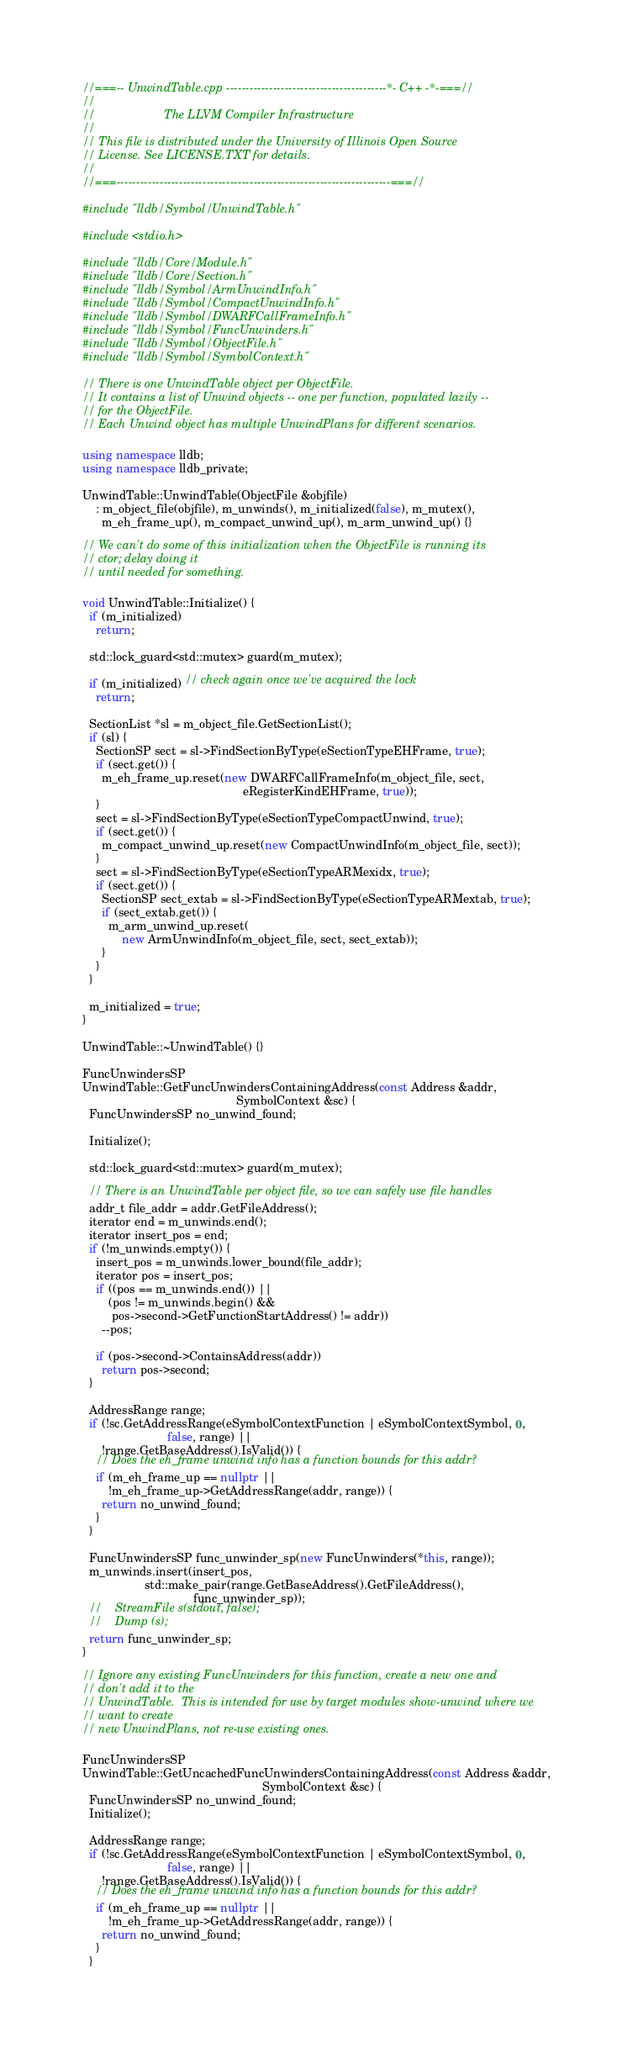<code> <loc_0><loc_0><loc_500><loc_500><_C++_>//===-- UnwindTable.cpp -----------------------------------------*- C++ -*-===//
//
//                     The LLVM Compiler Infrastructure
//
// This file is distributed under the University of Illinois Open Source
// License. See LICENSE.TXT for details.
//
//===----------------------------------------------------------------------===//

#include "lldb/Symbol/UnwindTable.h"

#include <stdio.h>

#include "lldb/Core/Module.h"
#include "lldb/Core/Section.h"
#include "lldb/Symbol/ArmUnwindInfo.h"
#include "lldb/Symbol/CompactUnwindInfo.h"
#include "lldb/Symbol/DWARFCallFrameInfo.h"
#include "lldb/Symbol/FuncUnwinders.h"
#include "lldb/Symbol/ObjectFile.h"
#include "lldb/Symbol/SymbolContext.h"

// There is one UnwindTable object per ObjectFile.
// It contains a list of Unwind objects -- one per function, populated lazily --
// for the ObjectFile.
// Each Unwind object has multiple UnwindPlans for different scenarios.

using namespace lldb;
using namespace lldb_private;

UnwindTable::UnwindTable(ObjectFile &objfile)
    : m_object_file(objfile), m_unwinds(), m_initialized(false), m_mutex(),
      m_eh_frame_up(), m_compact_unwind_up(), m_arm_unwind_up() {}

// We can't do some of this initialization when the ObjectFile is running its
// ctor; delay doing it
// until needed for something.

void UnwindTable::Initialize() {
  if (m_initialized)
    return;

  std::lock_guard<std::mutex> guard(m_mutex);

  if (m_initialized) // check again once we've acquired the lock
    return;

  SectionList *sl = m_object_file.GetSectionList();
  if (sl) {
    SectionSP sect = sl->FindSectionByType(eSectionTypeEHFrame, true);
    if (sect.get()) {
      m_eh_frame_up.reset(new DWARFCallFrameInfo(m_object_file, sect,
                                                 eRegisterKindEHFrame, true));
    }
    sect = sl->FindSectionByType(eSectionTypeCompactUnwind, true);
    if (sect.get()) {
      m_compact_unwind_up.reset(new CompactUnwindInfo(m_object_file, sect));
    }
    sect = sl->FindSectionByType(eSectionTypeARMexidx, true);
    if (sect.get()) {
      SectionSP sect_extab = sl->FindSectionByType(eSectionTypeARMextab, true);
      if (sect_extab.get()) {
        m_arm_unwind_up.reset(
            new ArmUnwindInfo(m_object_file, sect, sect_extab));
      }
    }
  }

  m_initialized = true;
}

UnwindTable::~UnwindTable() {}

FuncUnwindersSP
UnwindTable::GetFuncUnwindersContainingAddress(const Address &addr,
                                               SymbolContext &sc) {
  FuncUnwindersSP no_unwind_found;

  Initialize();

  std::lock_guard<std::mutex> guard(m_mutex);

  // There is an UnwindTable per object file, so we can safely use file handles
  addr_t file_addr = addr.GetFileAddress();
  iterator end = m_unwinds.end();
  iterator insert_pos = end;
  if (!m_unwinds.empty()) {
    insert_pos = m_unwinds.lower_bound(file_addr);
    iterator pos = insert_pos;
    if ((pos == m_unwinds.end()) ||
        (pos != m_unwinds.begin() &&
         pos->second->GetFunctionStartAddress() != addr))
      --pos;

    if (pos->second->ContainsAddress(addr))
      return pos->second;
  }

  AddressRange range;
  if (!sc.GetAddressRange(eSymbolContextFunction | eSymbolContextSymbol, 0,
                          false, range) ||
      !range.GetBaseAddress().IsValid()) {
    // Does the eh_frame unwind info has a function bounds for this addr?
    if (m_eh_frame_up == nullptr ||
        !m_eh_frame_up->GetAddressRange(addr, range)) {
      return no_unwind_found;
    }
  }

  FuncUnwindersSP func_unwinder_sp(new FuncUnwinders(*this, range));
  m_unwinds.insert(insert_pos,
                   std::make_pair(range.GetBaseAddress().GetFileAddress(),
                                  func_unwinder_sp));
  //    StreamFile s(stdout, false);
  //    Dump (s);
  return func_unwinder_sp;
}

// Ignore any existing FuncUnwinders for this function, create a new one and
// don't add it to the
// UnwindTable.  This is intended for use by target modules show-unwind where we
// want to create
// new UnwindPlans, not re-use existing ones.

FuncUnwindersSP
UnwindTable::GetUncachedFuncUnwindersContainingAddress(const Address &addr,
                                                       SymbolContext &sc) {
  FuncUnwindersSP no_unwind_found;
  Initialize();

  AddressRange range;
  if (!sc.GetAddressRange(eSymbolContextFunction | eSymbolContextSymbol, 0,
                          false, range) ||
      !range.GetBaseAddress().IsValid()) {
    // Does the eh_frame unwind info has a function bounds for this addr?
    if (m_eh_frame_up == nullptr ||
        !m_eh_frame_up->GetAddressRange(addr, range)) {
      return no_unwind_found;
    }
  }
</code> 